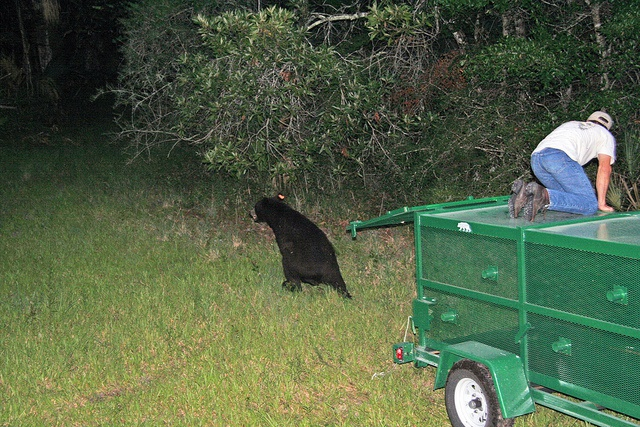Describe the objects in this image and their specific colors. I can see truck in black, darkgreen, green, and teal tones, people in black, white, and gray tones, and bear in black, gray, and darkgreen tones in this image. 